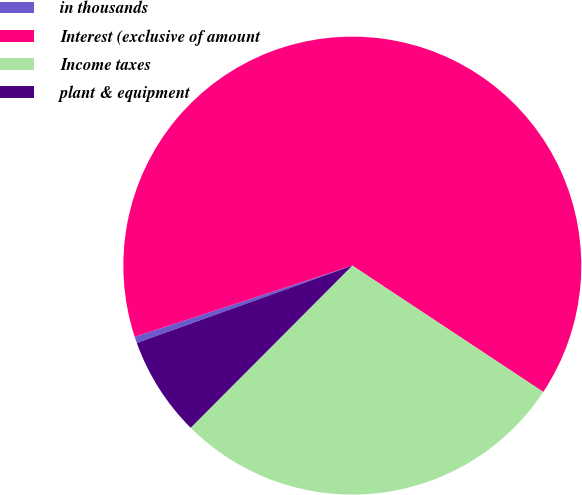Convert chart. <chart><loc_0><loc_0><loc_500><loc_500><pie_chart><fcel>in thousands<fcel>Interest (exclusive of amount<fcel>Income taxes<fcel>plant & equipment<nl><fcel>0.45%<fcel>64.34%<fcel>28.17%<fcel>7.04%<nl></chart> 